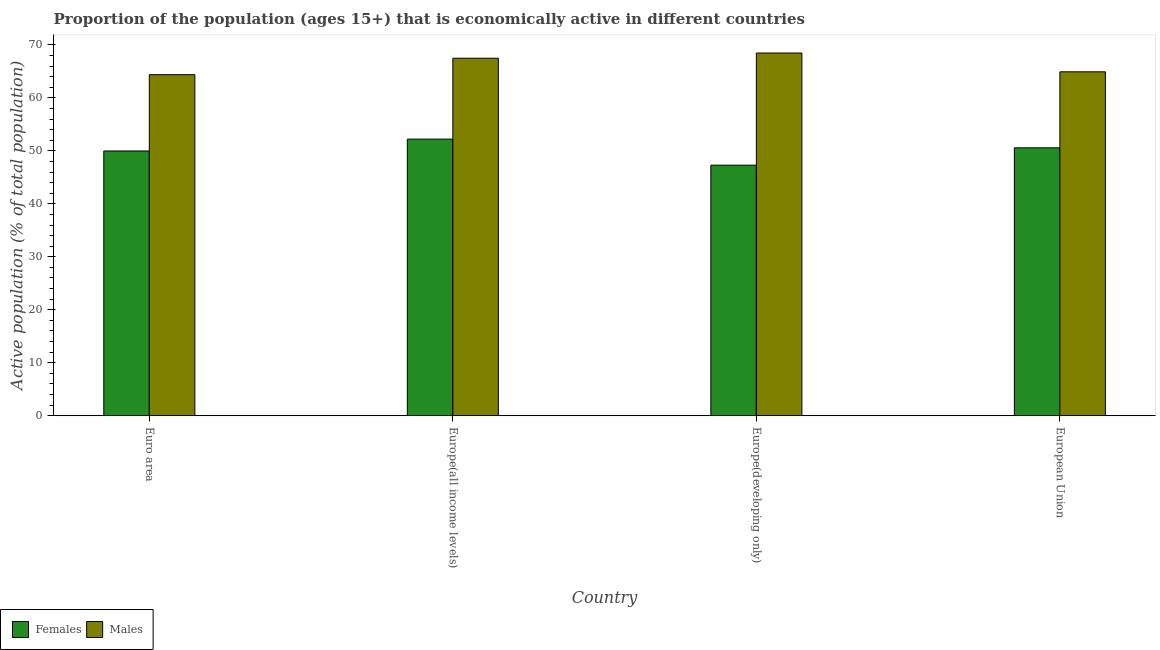How many different coloured bars are there?
Ensure brevity in your answer.  2. Are the number of bars on each tick of the X-axis equal?
Make the answer very short. Yes. How many bars are there on the 1st tick from the left?
Ensure brevity in your answer.  2. How many bars are there on the 2nd tick from the right?
Your answer should be compact. 2. What is the label of the 2nd group of bars from the left?
Your answer should be very brief. Europe(all income levels). What is the percentage of economically active female population in European Union?
Provide a succinct answer. 50.57. Across all countries, what is the maximum percentage of economically active female population?
Ensure brevity in your answer.  52.21. Across all countries, what is the minimum percentage of economically active female population?
Offer a very short reply. 47.3. In which country was the percentage of economically active female population maximum?
Your response must be concise. Europe(all income levels). In which country was the percentage of economically active male population minimum?
Make the answer very short. Euro area. What is the total percentage of economically active female population in the graph?
Offer a terse response. 200.06. What is the difference between the percentage of economically active female population in Europe(all income levels) and that in European Union?
Your response must be concise. 1.64. What is the difference between the percentage of economically active male population in Euro area and the percentage of economically active female population in Europe(all income levels)?
Your response must be concise. 12.16. What is the average percentage of economically active male population per country?
Provide a short and direct response. 66.31. What is the difference between the percentage of economically active female population and percentage of economically active male population in Euro area?
Your response must be concise. -14.4. What is the ratio of the percentage of economically active female population in Euro area to that in Europe(all income levels)?
Your answer should be very brief. 0.96. Is the difference between the percentage of economically active female population in Euro area and European Union greater than the difference between the percentage of economically active male population in Euro area and European Union?
Make the answer very short. No. What is the difference between the highest and the second highest percentage of economically active female population?
Provide a short and direct response. 1.64. What is the difference between the highest and the lowest percentage of economically active female population?
Offer a terse response. 4.92. What does the 2nd bar from the left in Euro area represents?
Provide a succinct answer. Males. What does the 1st bar from the right in Euro area represents?
Offer a very short reply. Males. How many bars are there?
Your answer should be very brief. 8. How many countries are there in the graph?
Give a very brief answer. 4. What is the difference between two consecutive major ticks on the Y-axis?
Your answer should be compact. 10. Does the graph contain any zero values?
Ensure brevity in your answer.  No. How are the legend labels stacked?
Keep it short and to the point. Horizontal. What is the title of the graph?
Your response must be concise. Proportion of the population (ages 15+) that is economically active in different countries. Does "Private creditors" appear as one of the legend labels in the graph?
Your response must be concise. No. What is the label or title of the X-axis?
Provide a succinct answer. Country. What is the label or title of the Y-axis?
Keep it short and to the point. Active population (% of total population). What is the Active population (% of total population) in Females in Euro area?
Ensure brevity in your answer.  49.98. What is the Active population (% of total population) of Males in Euro area?
Keep it short and to the point. 64.38. What is the Active population (% of total population) of Females in Europe(all income levels)?
Keep it short and to the point. 52.21. What is the Active population (% of total population) in Males in Europe(all income levels)?
Give a very brief answer. 67.49. What is the Active population (% of total population) in Females in Europe(developing only)?
Make the answer very short. 47.3. What is the Active population (% of total population) in Males in Europe(developing only)?
Offer a very short reply. 68.47. What is the Active population (% of total population) of Females in European Union?
Your response must be concise. 50.57. What is the Active population (% of total population) of Males in European Union?
Offer a very short reply. 64.92. Across all countries, what is the maximum Active population (% of total population) in Females?
Your response must be concise. 52.21. Across all countries, what is the maximum Active population (% of total population) in Males?
Offer a terse response. 68.47. Across all countries, what is the minimum Active population (% of total population) in Females?
Your answer should be very brief. 47.3. Across all countries, what is the minimum Active population (% of total population) of Males?
Provide a succinct answer. 64.38. What is the total Active population (% of total population) in Females in the graph?
Give a very brief answer. 200.06. What is the total Active population (% of total population) in Males in the graph?
Offer a terse response. 265.26. What is the difference between the Active population (% of total population) in Females in Euro area and that in Europe(all income levels)?
Keep it short and to the point. -2.24. What is the difference between the Active population (% of total population) of Males in Euro area and that in Europe(all income levels)?
Provide a short and direct response. -3.11. What is the difference between the Active population (% of total population) in Females in Euro area and that in Europe(developing only)?
Ensure brevity in your answer.  2.68. What is the difference between the Active population (% of total population) in Males in Euro area and that in Europe(developing only)?
Ensure brevity in your answer.  -4.09. What is the difference between the Active population (% of total population) of Females in Euro area and that in European Union?
Offer a very short reply. -0.59. What is the difference between the Active population (% of total population) of Males in Euro area and that in European Union?
Provide a short and direct response. -0.54. What is the difference between the Active population (% of total population) of Females in Europe(all income levels) and that in Europe(developing only)?
Make the answer very short. 4.92. What is the difference between the Active population (% of total population) in Males in Europe(all income levels) and that in Europe(developing only)?
Offer a terse response. -0.99. What is the difference between the Active population (% of total population) in Females in Europe(all income levels) and that in European Union?
Your answer should be very brief. 1.64. What is the difference between the Active population (% of total population) of Males in Europe(all income levels) and that in European Union?
Your answer should be compact. 2.56. What is the difference between the Active population (% of total population) of Females in Europe(developing only) and that in European Union?
Ensure brevity in your answer.  -3.27. What is the difference between the Active population (% of total population) in Males in Europe(developing only) and that in European Union?
Your response must be concise. 3.55. What is the difference between the Active population (% of total population) of Females in Euro area and the Active population (% of total population) of Males in Europe(all income levels)?
Your answer should be compact. -17.51. What is the difference between the Active population (% of total population) in Females in Euro area and the Active population (% of total population) in Males in Europe(developing only)?
Keep it short and to the point. -18.49. What is the difference between the Active population (% of total population) of Females in Euro area and the Active population (% of total population) of Males in European Union?
Your response must be concise. -14.94. What is the difference between the Active population (% of total population) in Females in Europe(all income levels) and the Active population (% of total population) in Males in Europe(developing only)?
Offer a terse response. -16.26. What is the difference between the Active population (% of total population) in Females in Europe(all income levels) and the Active population (% of total population) in Males in European Union?
Provide a short and direct response. -12.71. What is the difference between the Active population (% of total population) of Females in Europe(developing only) and the Active population (% of total population) of Males in European Union?
Your answer should be compact. -17.62. What is the average Active population (% of total population) in Females per country?
Your response must be concise. 50.02. What is the average Active population (% of total population) in Males per country?
Offer a very short reply. 66.31. What is the difference between the Active population (% of total population) in Females and Active population (% of total population) in Males in Euro area?
Your answer should be compact. -14.4. What is the difference between the Active population (% of total population) of Females and Active population (% of total population) of Males in Europe(all income levels)?
Ensure brevity in your answer.  -15.27. What is the difference between the Active population (% of total population) in Females and Active population (% of total population) in Males in Europe(developing only)?
Offer a very short reply. -21.17. What is the difference between the Active population (% of total population) of Females and Active population (% of total population) of Males in European Union?
Provide a succinct answer. -14.35. What is the ratio of the Active population (% of total population) in Females in Euro area to that in Europe(all income levels)?
Provide a short and direct response. 0.96. What is the ratio of the Active population (% of total population) in Males in Euro area to that in Europe(all income levels)?
Your answer should be compact. 0.95. What is the ratio of the Active population (% of total population) in Females in Euro area to that in Europe(developing only)?
Offer a very short reply. 1.06. What is the ratio of the Active population (% of total population) of Males in Euro area to that in Europe(developing only)?
Your answer should be compact. 0.94. What is the ratio of the Active population (% of total population) of Females in Euro area to that in European Union?
Give a very brief answer. 0.99. What is the ratio of the Active population (% of total population) in Females in Europe(all income levels) to that in Europe(developing only)?
Keep it short and to the point. 1.1. What is the ratio of the Active population (% of total population) in Males in Europe(all income levels) to that in Europe(developing only)?
Your answer should be very brief. 0.99. What is the ratio of the Active population (% of total population) of Females in Europe(all income levels) to that in European Union?
Provide a succinct answer. 1.03. What is the ratio of the Active population (% of total population) of Males in Europe(all income levels) to that in European Union?
Give a very brief answer. 1.04. What is the ratio of the Active population (% of total population) in Females in Europe(developing only) to that in European Union?
Give a very brief answer. 0.94. What is the ratio of the Active population (% of total population) of Males in Europe(developing only) to that in European Union?
Give a very brief answer. 1.05. What is the difference between the highest and the second highest Active population (% of total population) in Females?
Your answer should be compact. 1.64. What is the difference between the highest and the second highest Active population (% of total population) of Males?
Provide a short and direct response. 0.99. What is the difference between the highest and the lowest Active population (% of total population) of Females?
Your answer should be very brief. 4.92. What is the difference between the highest and the lowest Active population (% of total population) in Males?
Give a very brief answer. 4.09. 